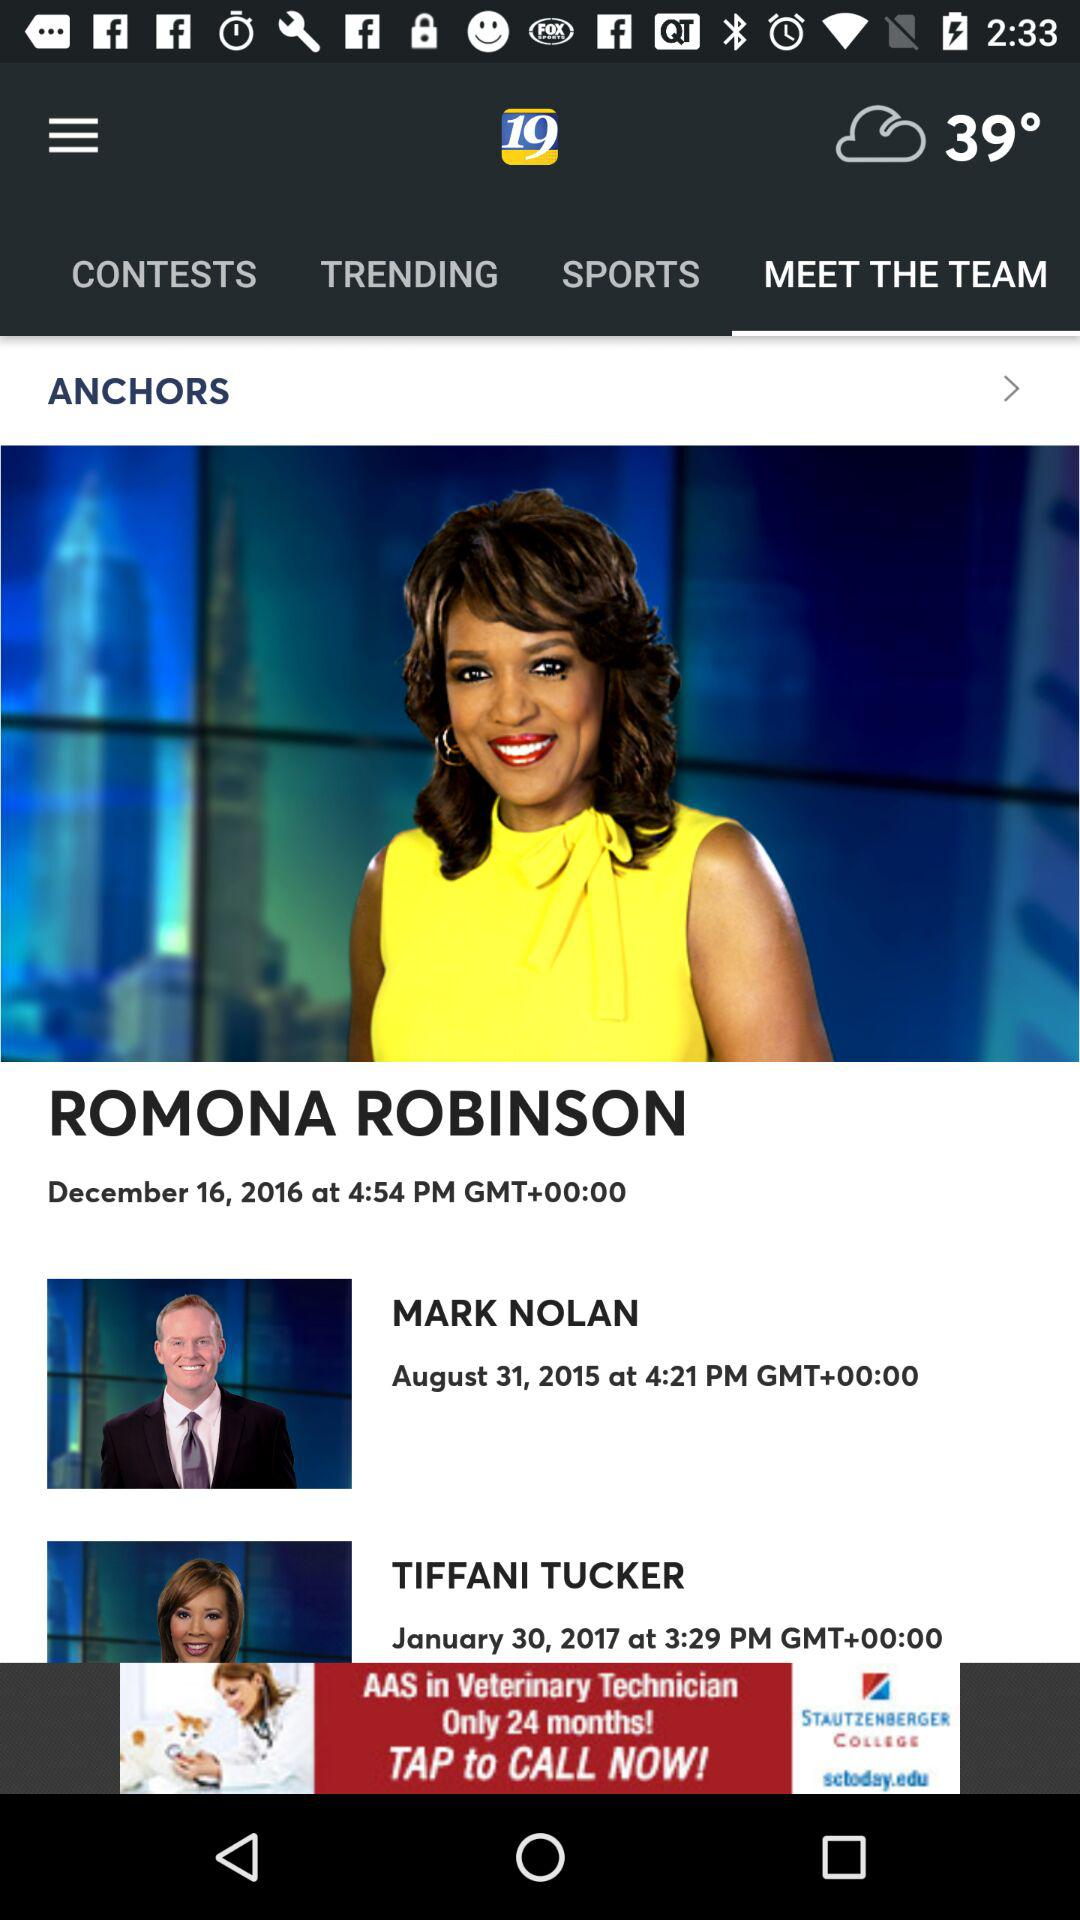Which tab is currently selected? The tab "MEET THE TEAM" is currently selected. 